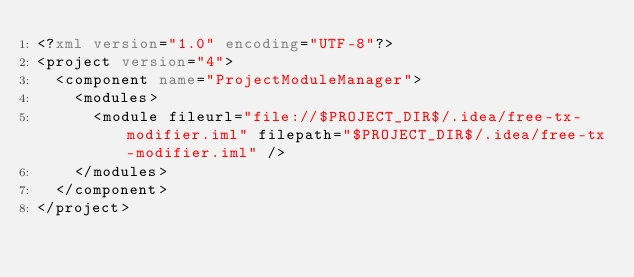<code> <loc_0><loc_0><loc_500><loc_500><_XML_><?xml version="1.0" encoding="UTF-8"?>
<project version="4">
  <component name="ProjectModuleManager">
    <modules>
      <module fileurl="file://$PROJECT_DIR$/.idea/free-tx-modifier.iml" filepath="$PROJECT_DIR$/.idea/free-tx-modifier.iml" />
    </modules>
  </component>
</project></code> 